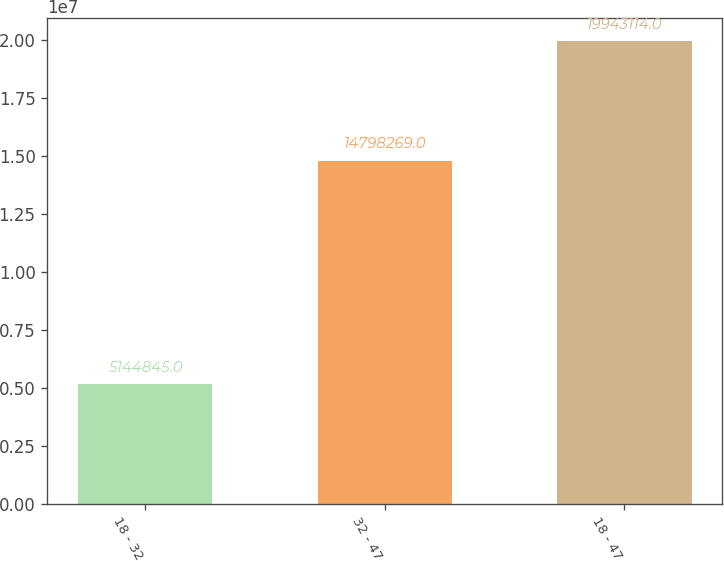Convert chart to OTSL. <chart><loc_0><loc_0><loc_500><loc_500><bar_chart><fcel>18 - 32<fcel>32 - 47<fcel>18 - 47<nl><fcel>5.14484e+06<fcel>1.47983e+07<fcel>1.99431e+07<nl></chart> 